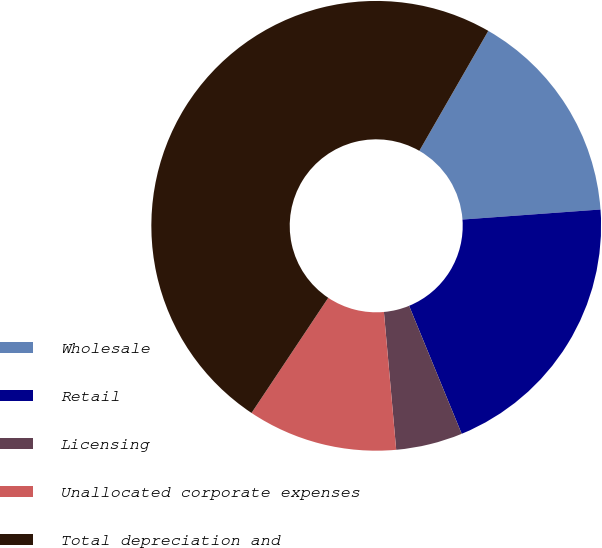<chart> <loc_0><loc_0><loc_500><loc_500><pie_chart><fcel>Wholesale<fcel>Retail<fcel>Licensing<fcel>Unallocated corporate expenses<fcel>Total depreciation and<nl><fcel>15.54%<fcel>19.95%<fcel>4.79%<fcel>10.77%<fcel>48.95%<nl></chart> 